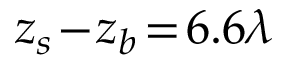Convert formula to latex. <formula><loc_0><loc_0><loc_500><loc_500>z _ { s } \, - \, z _ { b } \, = \, 6 . 6 \lambda</formula> 